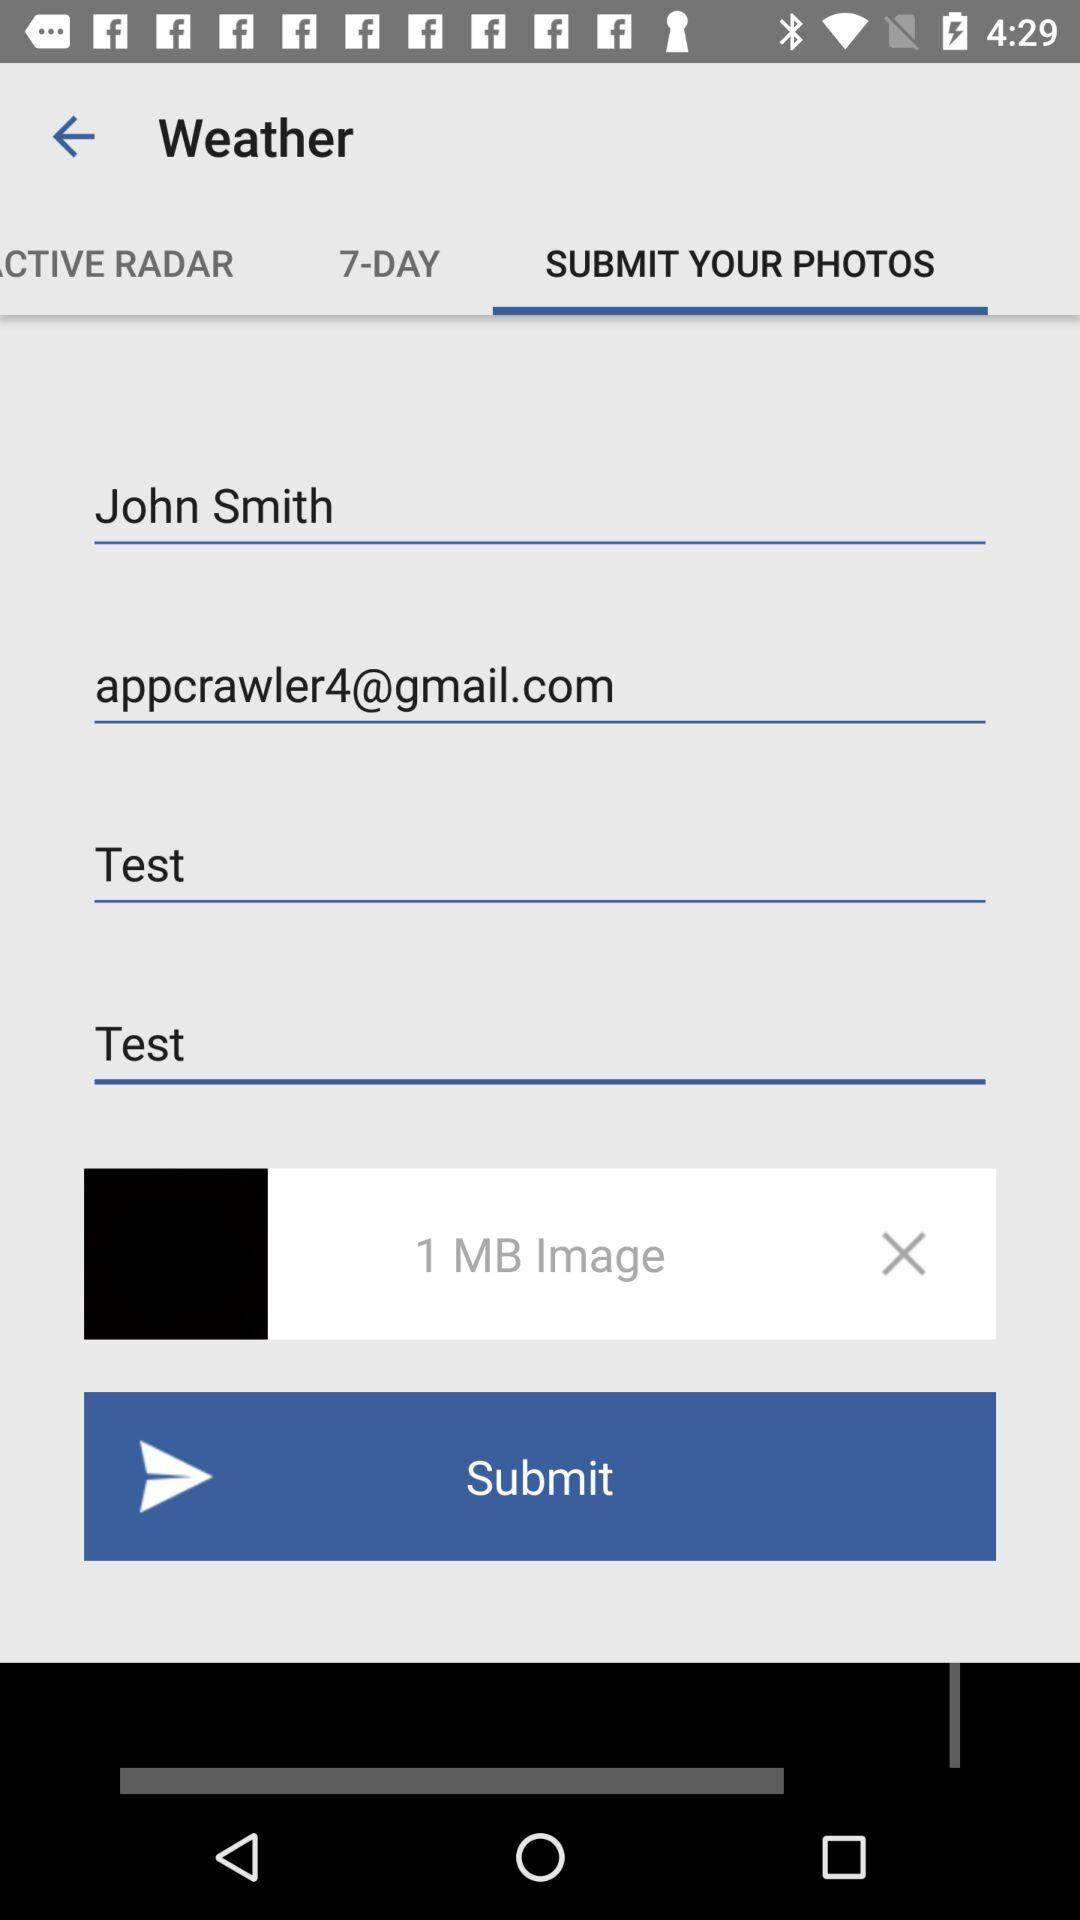What is the email address? The email address is appcrawler4@gmail.com. 